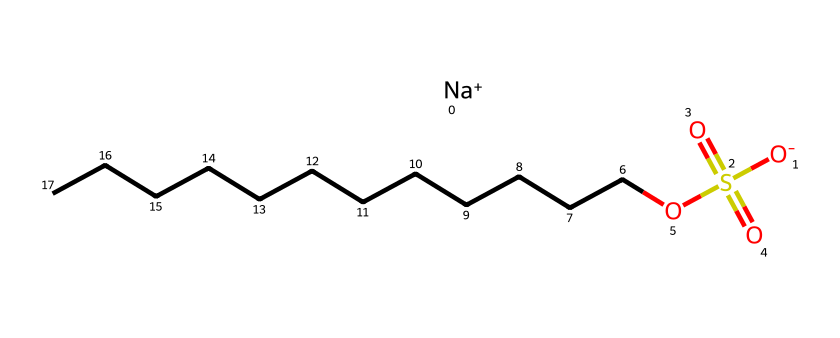What is the full name of this chemical? The full name of the chemical represented by this SMILES is Sodium Dodecyl Sulfate. The SMILES shows the sodium cation ([Na+]) and the dodecyl (a 12-carbon chain) sulfates as a sulfate ester (-S(=O)(=O)O-).
Answer: Sodium Dodecyl Sulfate How many carbon atoms are in the dodecyl chain? The dodecyl chain is represented by "CCCCCCCCCCCC," which indicates a hydrocarbon chain with 12 carbon atoms. Each "C" corresponds to a carbon atom, and there are 12 total.
Answer: 12 What charge does the sodium ion carry? The chemical structure indicates that sodium is depicted as [Na+], showing that it carries a positive charge.
Answer: positive How many sulfur atoms are present in the structure? Analyzing the SMILES, it shows one instance of "S" in the sulfate group, indicating there is one sulfur atom present in the structure.
Answer: 1 What type of functional group is present in this chemical? The SMILES reveals a sulfate portion, S(=O)(=O)O, which corresponds to the sulfate functional group. This indicates the presence of a sulfate ester linked to the dodecyl chain.
Answer: sulfate Which part of this chemical makes it a surfactant? The presence of both hydrophobic (the long alkyl chain) and hydrophilic (the sulfate group) portions in the structure allows it to act as a surfactant by reducing the surface tension between water and oil.
Answer: both hydrophobic and hydrophilic 